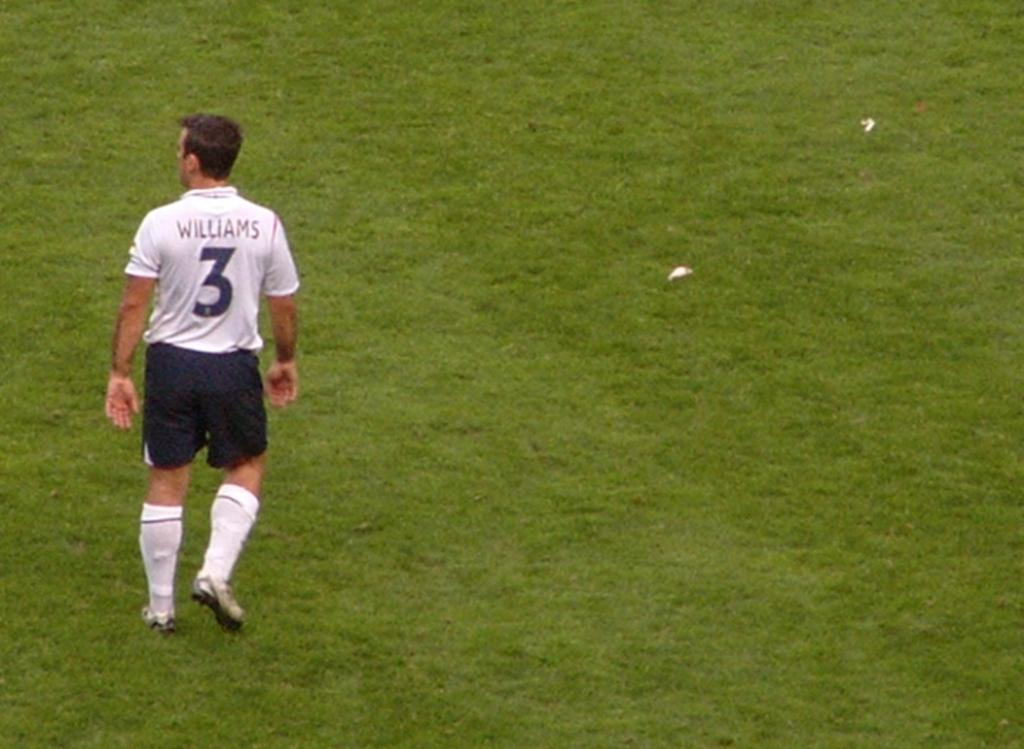<image>
Summarize the visual content of the image. a sports player with the name WILLIAMS and # on the back of his shirt standing on some grass. 